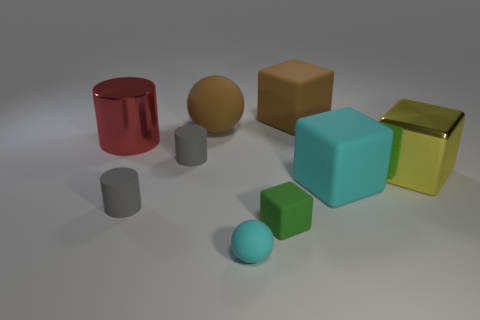Subtract all gray spheres. How many gray cylinders are left? 2 Subtract all small cylinders. How many cylinders are left? 1 Subtract all brown blocks. How many blocks are left? 3 Add 1 yellow shiny objects. How many objects exist? 10 Subtract all balls. How many objects are left? 7 Subtract all yellow cylinders. Subtract all cyan cubes. How many cylinders are left? 3 Add 3 brown things. How many brown things are left? 5 Add 6 spheres. How many spheres exist? 8 Subtract 1 brown cubes. How many objects are left? 8 Subtract all big brown balls. Subtract all brown blocks. How many objects are left? 7 